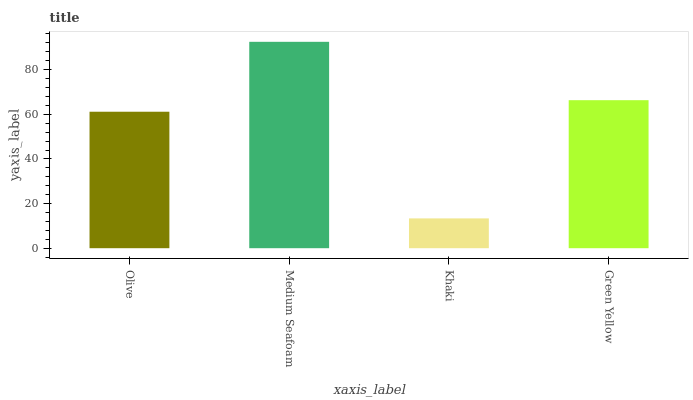Is Khaki the minimum?
Answer yes or no. Yes. Is Medium Seafoam the maximum?
Answer yes or no. Yes. Is Medium Seafoam the minimum?
Answer yes or no. No. Is Khaki the maximum?
Answer yes or no. No. Is Medium Seafoam greater than Khaki?
Answer yes or no. Yes. Is Khaki less than Medium Seafoam?
Answer yes or no. Yes. Is Khaki greater than Medium Seafoam?
Answer yes or no. No. Is Medium Seafoam less than Khaki?
Answer yes or no. No. Is Green Yellow the high median?
Answer yes or no. Yes. Is Olive the low median?
Answer yes or no. Yes. Is Medium Seafoam the high median?
Answer yes or no. No. Is Medium Seafoam the low median?
Answer yes or no. No. 